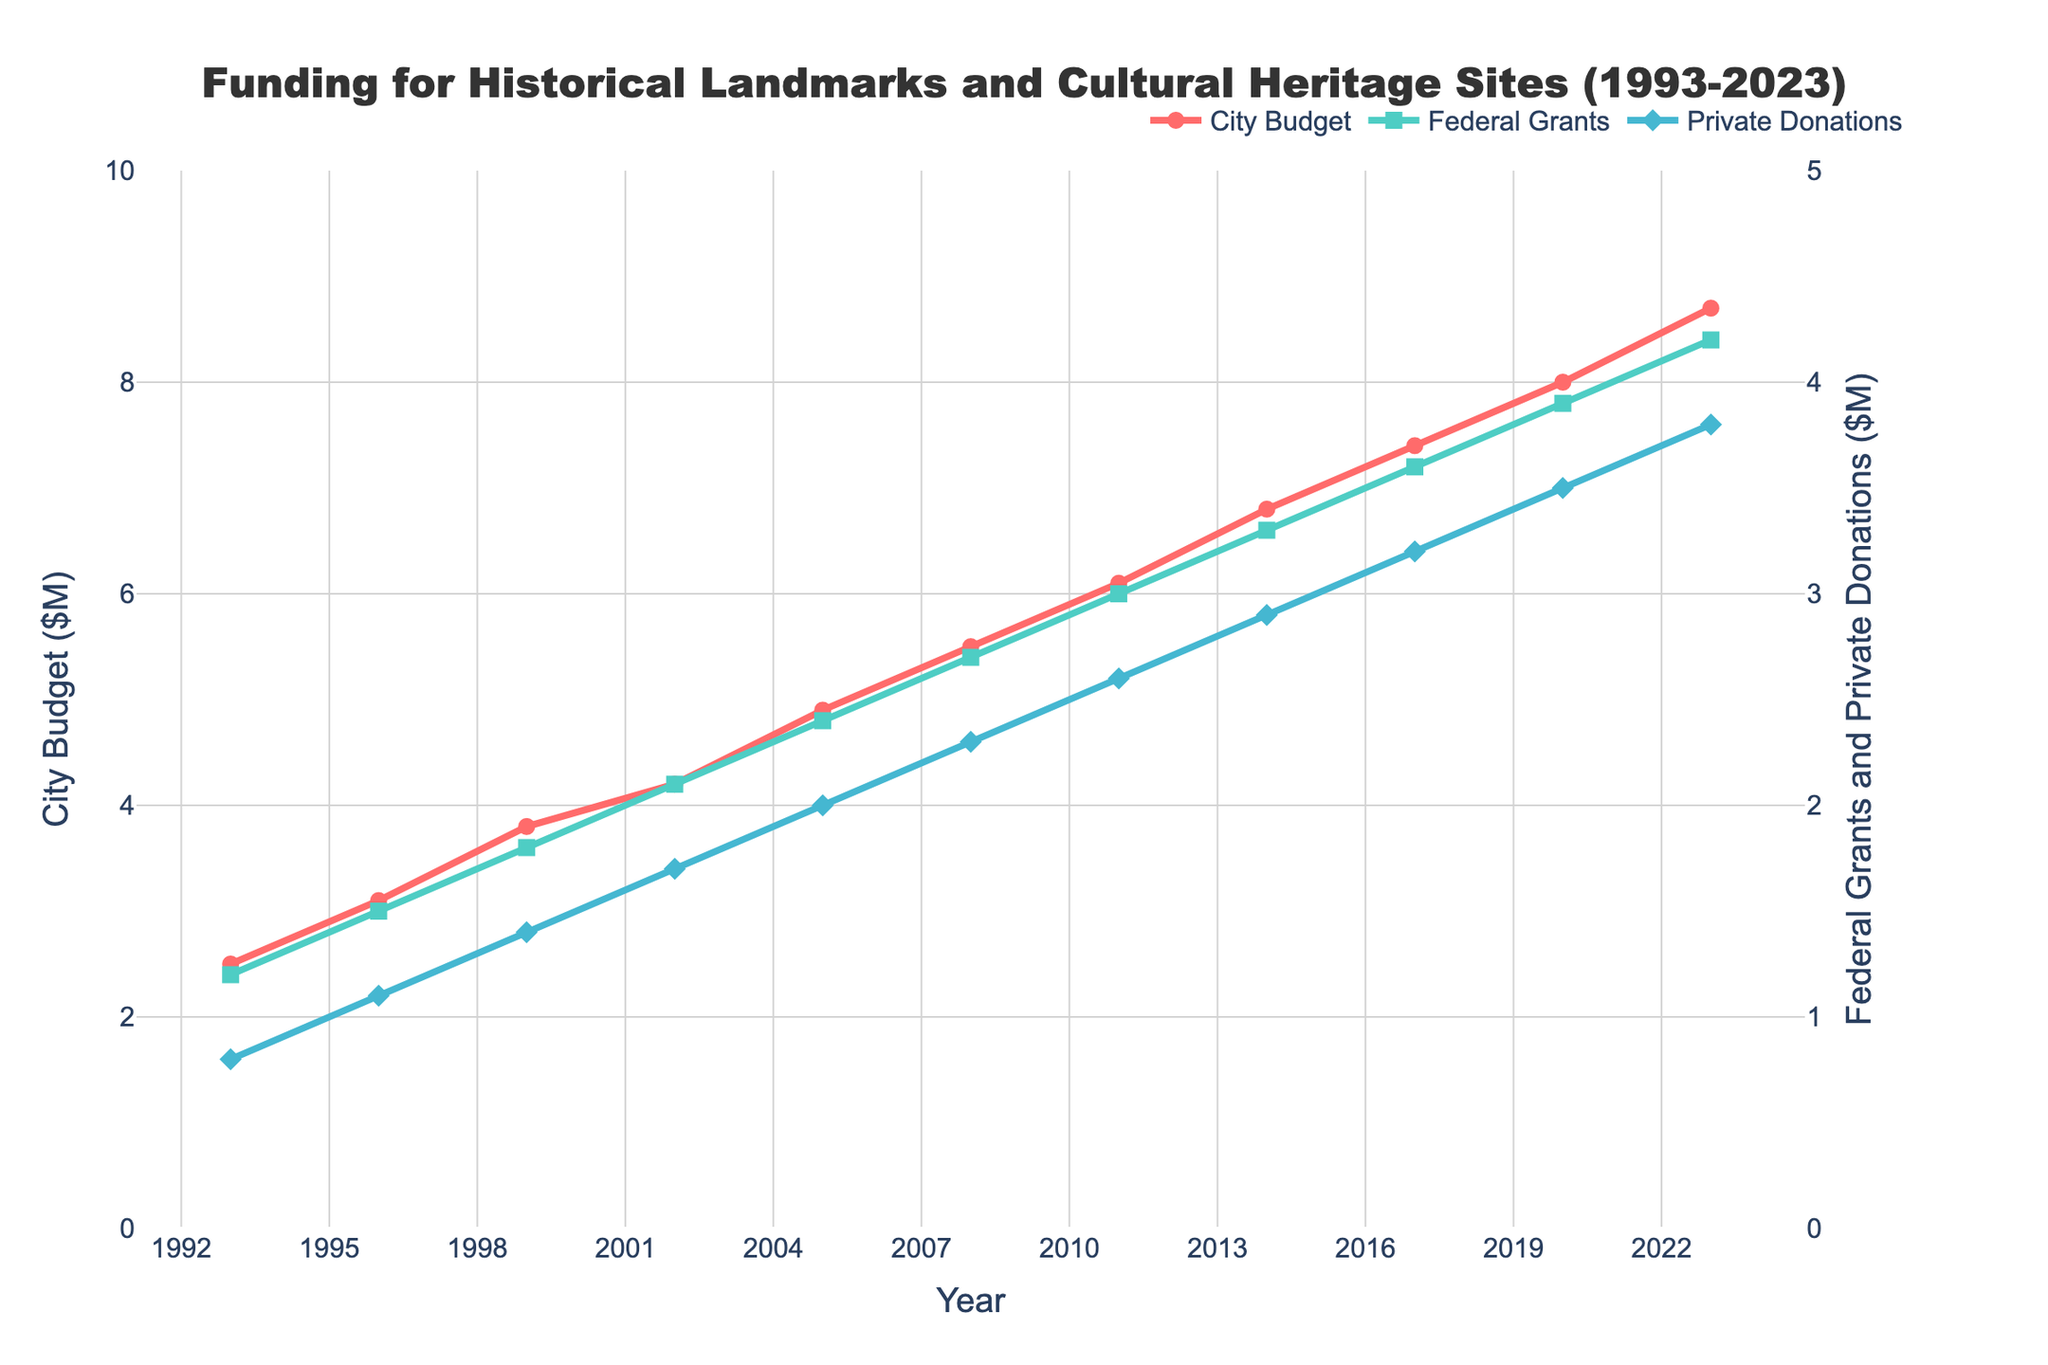Which year had the highest city budget for heritage preservation? The city budget for heritage preservation is represented by the red line in the chart. The highest point on this line indicates the maximum budget. The peak occurs in 2023.
Answer: 2023 How much did the city budget for heritage preservation increase from 1993 to 2023? The city budget for heritage preservation increased from $2.5M in 1993 to $8.7M in 2023. The difference is $8.7M - $2.5M.
Answer: $6.2M In which years were the federal grants equal to or greater than private donations? The federal grants (green line) are equal to or greater than private donations (blue line) in all years displayed in the chart.
Answer: All years What is the average amount of federal grants received between 2005 and 2023? The federal grants amounts from 2005 to 2023 are $2.4M, $2.7M, $3.0M, $3.3M, $3.6M, $3.9M, and $4.2M. Summing these and dividing by the number of years (7) gives the average. (2.4 + 2.7 + 3.0 + 3.3 + 3.6 + 3.9 + 4.2) / 7.
Answer: $3.44M Which funding source saw the largest absolute increase from 1993 to 2023? Compare the increases for city budget, federal grants, and private donations. City budget increased by $6.2M, federal grants by $3.0M ($4.2M - $1.2M), and private donations by $3.0M ($3.8M - $0.8M). The largest increase is for the city budget.
Answer: City budget Between which years did the city budget for heritage preservation see the largest single increase? Examine the red line for the steepest segment. From 2017 to 2020, the budget increased from $7.4M to $8.0M, which is an increase of $0.6M. This is the highest increment compared to other periods.
Answer: 2017 to 2020 How did private donations change from 2017 to 2023? Private donations increased from $3.2M in 2017 to $3.8M in 2023. The difference is $3.8M - $3.2M.
Answer: $0.6M Which year had the smallest difference between federal grants and private donations? To find this, subtract private donations from federal grants for each year and find the smallest difference. The smallest difference is $0.3M, observed in 2002 ($2.1M for federal grants - $1.7M for private donations).
Answer: 2002 What is the total amount of city budget for heritage preservation over the entire period? Sum the values for the city budget from 1993 to 2023: $2.5M + $3.1M + $3.8M + $4.2M + $4.9M + $5.5M + $6.1M + $6.8M + $7.4M + $8.0M + $8.7M.
Answer: $60M 